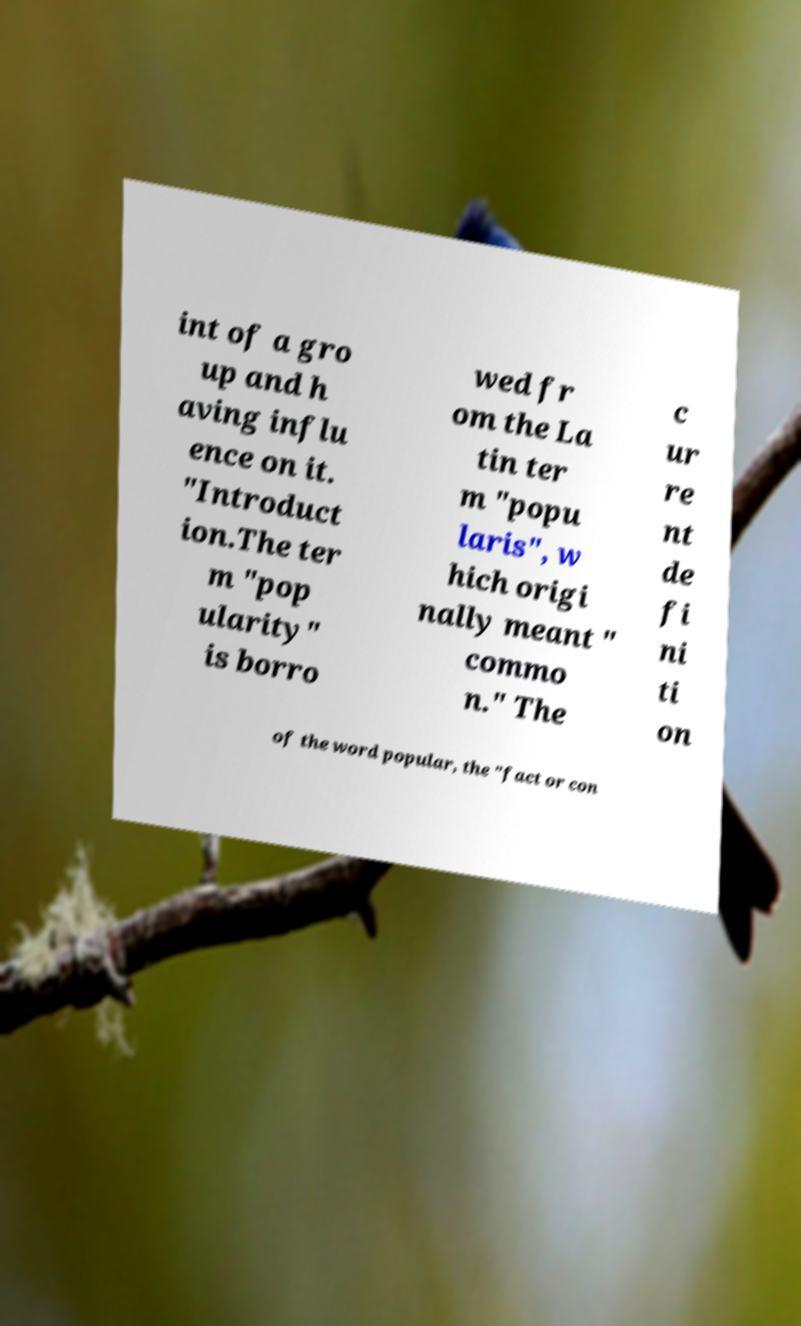For documentation purposes, I need the text within this image transcribed. Could you provide that? int of a gro up and h aving influ ence on it. "Introduct ion.The ter m "pop ularity" is borro wed fr om the La tin ter m "popu laris", w hich origi nally meant " commo n." The c ur re nt de fi ni ti on of the word popular, the "fact or con 